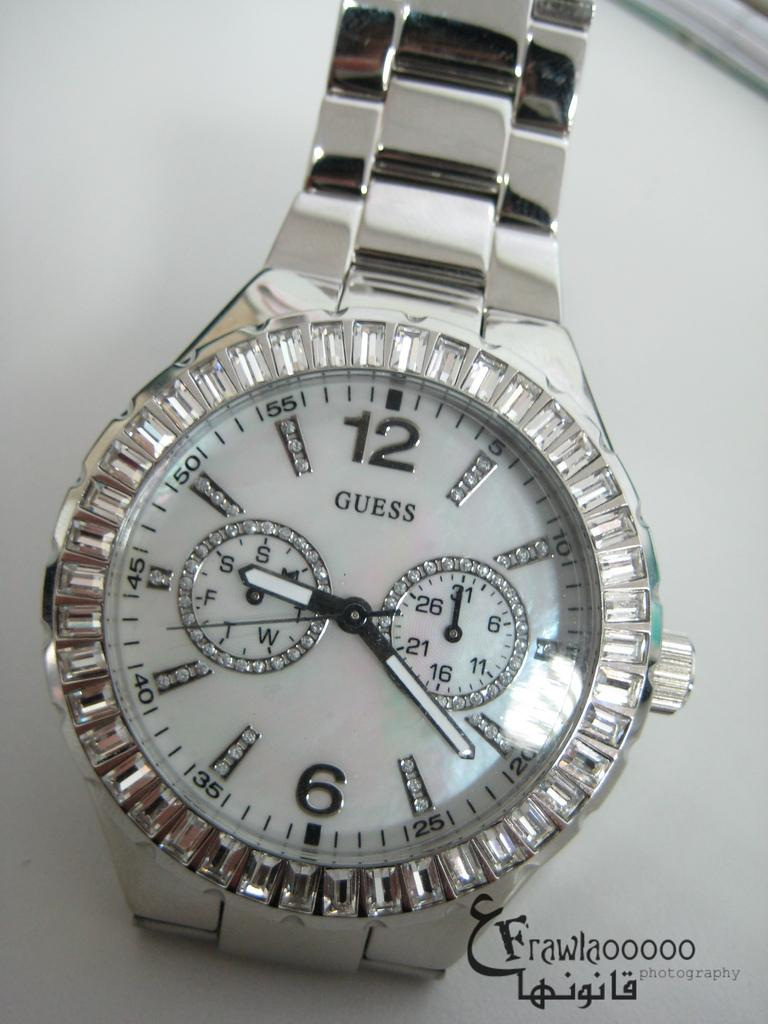<image>
Provide a brief description of the given image. a close up of a Guess silver wrist watch on a table 